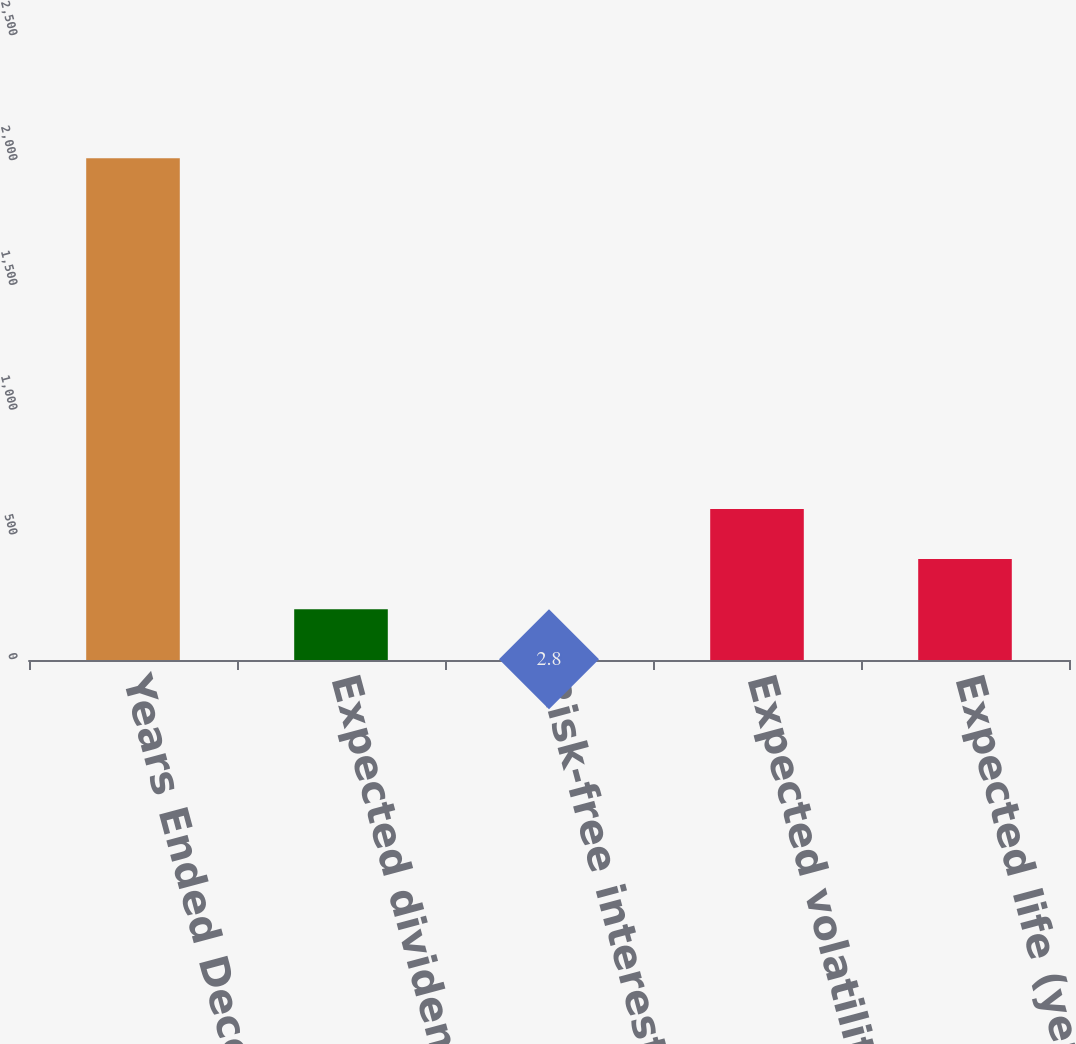Convert chart. <chart><loc_0><loc_0><loc_500><loc_500><bar_chart><fcel>Years Ended December 31<fcel>Expected dividend yield<fcel>Risk-free interest rate<fcel>Expected volatility<fcel>Expected life (years)<nl><fcel>2010<fcel>203.52<fcel>2.8<fcel>604.96<fcel>404.24<nl></chart> 